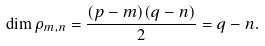Convert formula to latex. <formula><loc_0><loc_0><loc_500><loc_500>\dim \rho _ { m , n } = \frac { ( p - m ) ( q - n ) } { 2 } = q - n .</formula> 